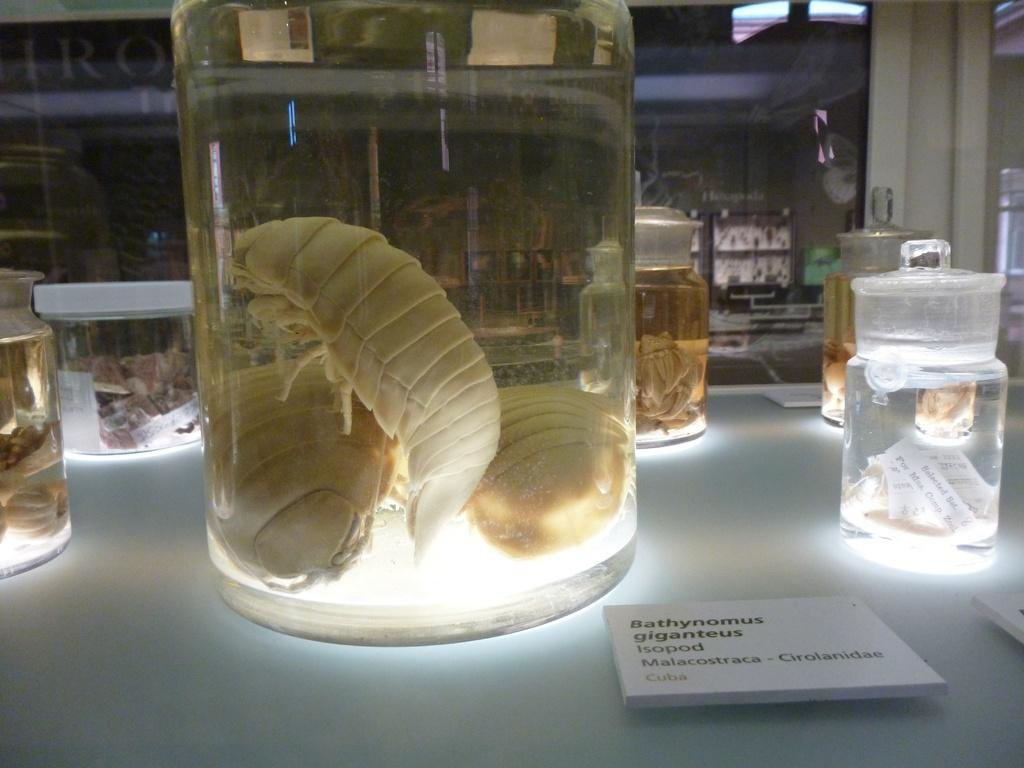<image>
Provide a brief description of the given image. Several enormous Isopods in a jar are labelled Bathynomus Giganteus. 